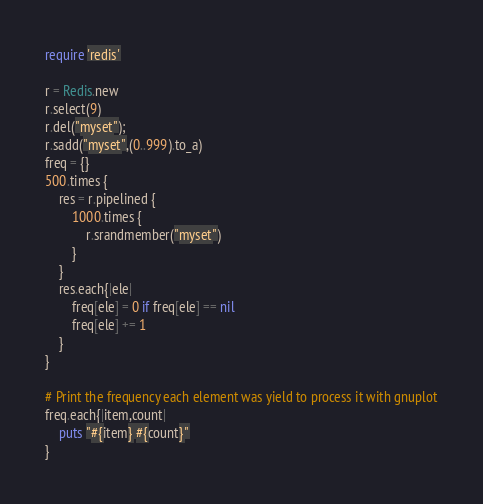Convert code to text. <code><loc_0><loc_0><loc_500><loc_500><_Ruby_>require 'redis'

r = Redis.new
r.select(9)
r.del("myset");
r.sadd("myset",(0..999).to_a)
freq = {}
500.times {
    res = r.pipelined {
        1000.times {
            r.srandmember("myset")
        }
    }
    res.each{|ele|
        freq[ele] = 0 if freq[ele] == nil
        freq[ele] += 1
    }
}

# Print the frequency each element was yield to process it with gnuplot
freq.each{|item,count|
    puts "#{item} #{count}"
}
</code> 